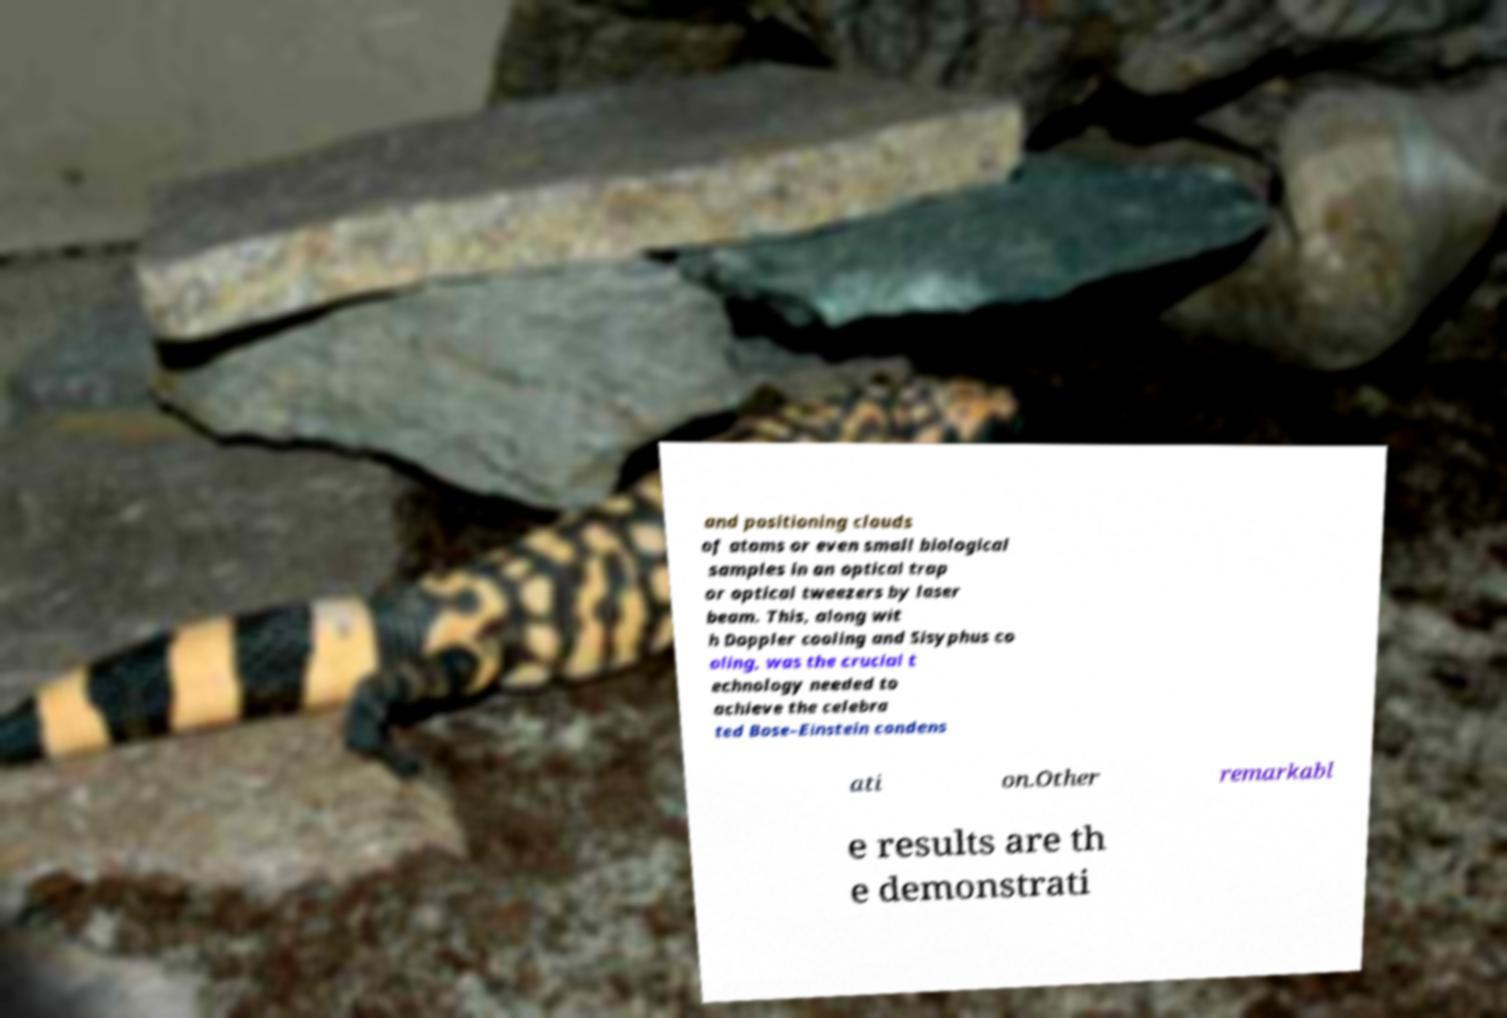I need the written content from this picture converted into text. Can you do that? and positioning clouds of atoms or even small biological samples in an optical trap or optical tweezers by laser beam. This, along wit h Doppler cooling and Sisyphus co oling, was the crucial t echnology needed to achieve the celebra ted Bose–Einstein condens ati on.Other remarkabl e results are th e demonstrati 